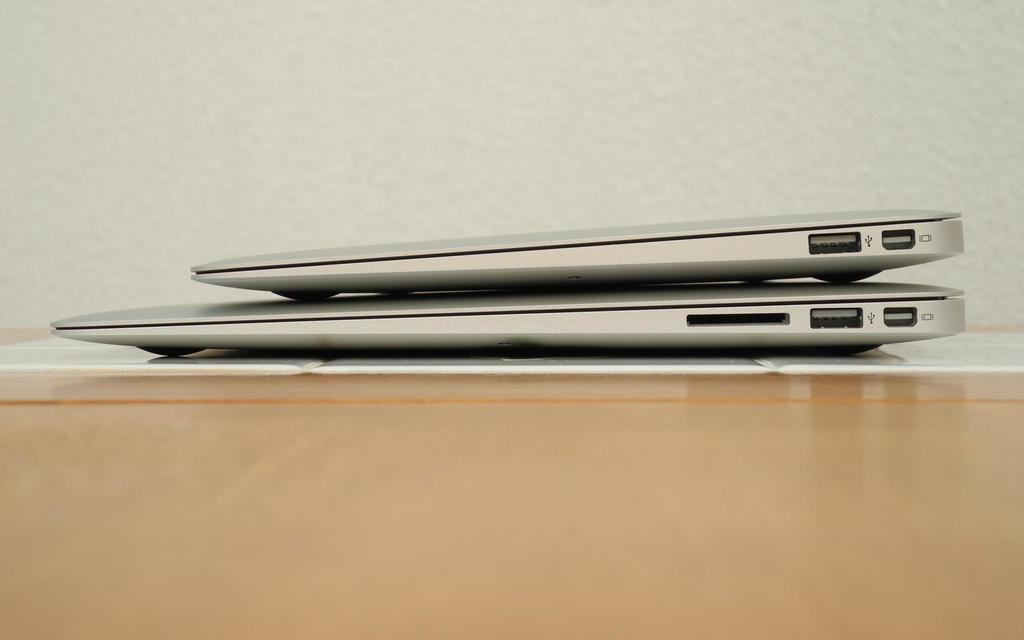How many laptops are visible in the image? There are two laptops in the image. What is the arrangement of the laptops? The laptops are stacked on top of each other. What is the color of the table in the image? The table is white in color. What can be seen at the top of the image? There is a wall visible at the top of the image. What type of yak can be seen in the image? There is no yak present in the image. Can you describe the facial expressions of the people in the image? There are no people present in the image, so facial expressions cannot be described. 